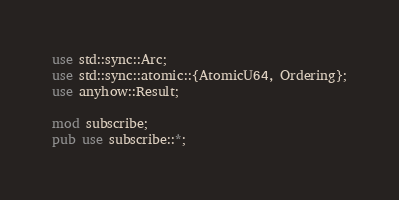Convert code to text. <code><loc_0><loc_0><loc_500><loc_500><_Rust_>use std::sync::Arc;
use std::sync::atomic::{AtomicU64, Ordering};
use anyhow::Result;

mod subscribe;
pub use subscribe::*;
</code> 